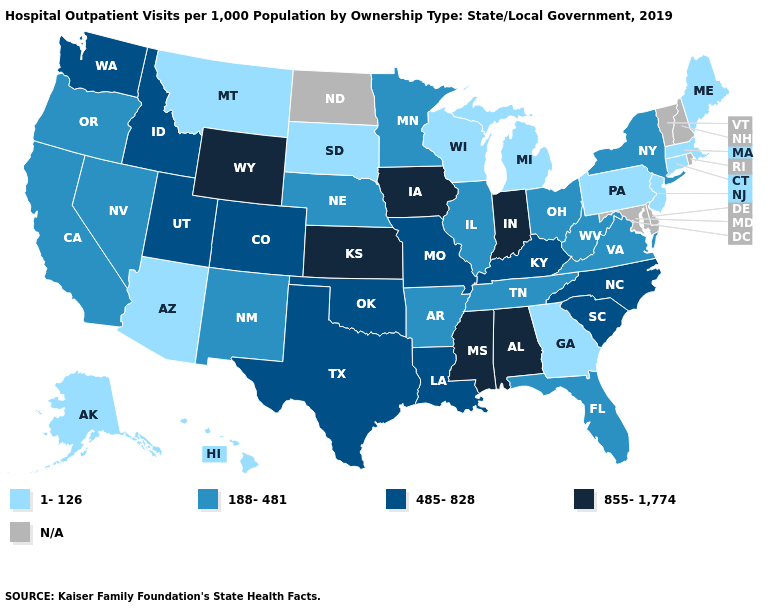Name the states that have a value in the range 188-481?
Give a very brief answer. Arkansas, California, Florida, Illinois, Minnesota, Nebraska, Nevada, New Mexico, New York, Ohio, Oregon, Tennessee, Virginia, West Virginia. Which states have the lowest value in the USA?
Short answer required. Alaska, Arizona, Connecticut, Georgia, Hawaii, Maine, Massachusetts, Michigan, Montana, New Jersey, Pennsylvania, South Dakota, Wisconsin. Which states hav the highest value in the West?
Keep it brief. Wyoming. Among the states that border New Jersey , does New York have the lowest value?
Keep it brief. No. Does the first symbol in the legend represent the smallest category?
Answer briefly. Yes. Name the states that have a value in the range N/A?
Be succinct. Delaware, Maryland, New Hampshire, North Dakota, Rhode Island, Vermont. What is the lowest value in the USA?
Be succinct. 1-126. What is the lowest value in states that border Indiana?
Keep it brief. 1-126. Among the states that border Oklahoma , does Texas have the lowest value?
Give a very brief answer. No. How many symbols are there in the legend?
Quick response, please. 5. What is the value of Georgia?
Keep it brief. 1-126. Name the states that have a value in the range 188-481?
Give a very brief answer. Arkansas, California, Florida, Illinois, Minnesota, Nebraska, Nevada, New Mexico, New York, Ohio, Oregon, Tennessee, Virginia, West Virginia. Among the states that border Tennessee , which have the highest value?
Give a very brief answer. Alabama, Mississippi. Does the map have missing data?
Answer briefly. Yes. 